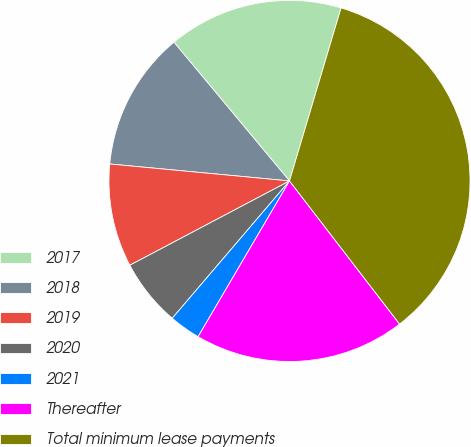Convert chart to OTSL. <chart><loc_0><loc_0><loc_500><loc_500><pie_chart><fcel>2017<fcel>2018<fcel>2019<fcel>2020<fcel>2021<fcel>Thereafter<fcel>Total minimum lease payments<nl><fcel>15.66%<fcel>12.45%<fcel>9.23%<fcel>6.02%<fcel>2.8%<fcel>18.88%<fcel>34.95%<nl></chart> 